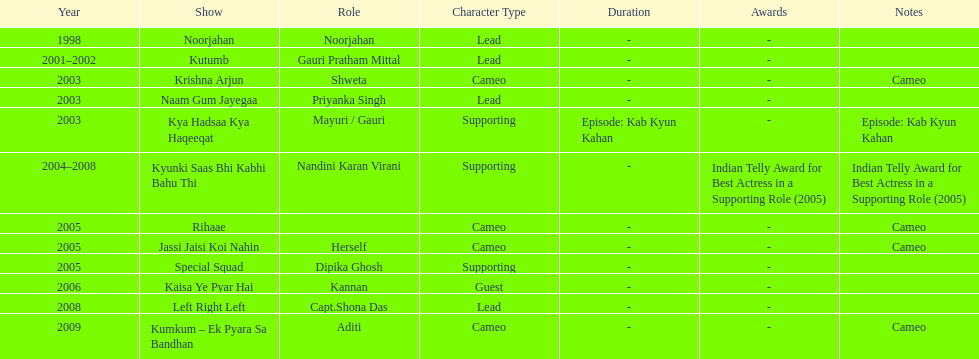In total, how many different tv series has gauri tejwani either starred or cameoed in? 11. 